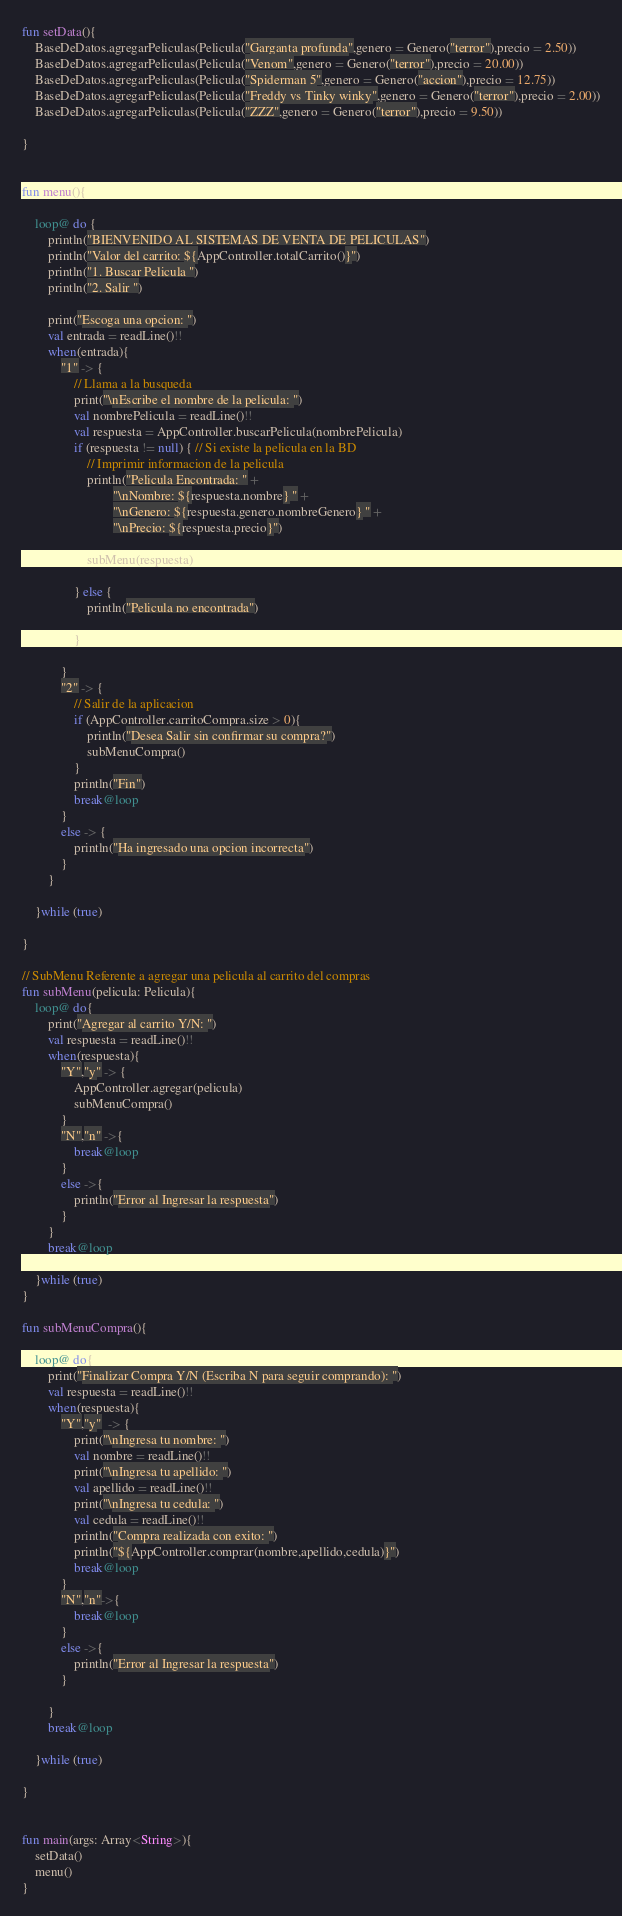Convert code to text. <code><loc_0><loc_0><loc_500><loc_500><_Kotlin_>fun setData(){
    BaseDeDatos.agregarPeliculas(Pelicula("Garganta profunda",genero = Genero("terror"),precio = 2.50))
    BaseDeDatos.agregarPeliculas(Pelicula("Venom",genero = Genero("terror"),precio = 20.00))
    BaseDeDatos.agregarPeliculas(Pelicula("Spiderman 5",genero = Genero("accion"),precio = 12.75))
    BaseDeDatos.agregarPeliculas(Pelicula("Freddy vs Tinky winky",genero = Genero("terror"),precio = 2.00))
    BaseDeDatos.agregarPeliculas(Pelicula("ZZZ",genero = Genero("terror"),precio = 9.50))

}


fun menu(){

    loop@ do {
        println("BIENVENIDO AL SISTEMAS DE VENTA DE PELICULAS")
        println("Valor del carrito: ${AppController.totalCarrito()}")
        println("1. Buscar Pelicula ")
        println("2. Salir ")

        print("Escoga una opcion: ")
        val entrada = readLine()!!
        when(entrada){
            "1" -> {
                // Llama a la busqueda
                print("\nEscribe el nombre de la pelicula: ")
                val nombrePelicula = readLine()!!
                val respuesta = AppController.buscarPelicula(nombrePelicula)
                if (respuesta != null) { // Si existe la pelicula en la BD
                    // Imprimir informacion de la pelicula
                    println("Pelicula Encontrada: " +
                            "\nNombre: ${respuesta.nombre} " +
                            "\nGenero: ${respuesta.genero.nombreGenero} " +
                            "\nPrecio: ${respuesta.precio}")

                    subMenu(respuesta)

                } else {
                    println("Pelicula no encontrada")

                }

            }
            "2" -> {
                // Salir de la aplicacion
                if (AppController.carritoCompra.size > 0){
                    println("Desea Salir sin confirmar su compra?")
                    subMenuCompra()
                }
                println("Fin")
                break@loop
            }
            else -> {
                println("Ha ingresado una opcion incorrecta")
            }
        }

    }while (true)

}

// SubMenu Referente a agregar una pelicula al carrito del compras
fun subMenu(pelicula: Pelicula){
    loop@ do{
        print("Agregar al carrito Y/N: ")
        val respuesta = readLine()!!
        when(respuesta){
            "Y","y" -> {
                AppController.agregar(pelicula)
                subMenuCompra()
            }
            "N","n" ->{
                break@loop
            }
            else ->{
                println("Error al Ingresar la respuesta")
            }
        }
        break@loop

    }while (true)
}

fun subMenuCompra(){

    loop@ do{
        print("Finalizar Compra Y/N (Escriba N para seguir comprando): ")
        val respuesta = readLine()!!
        when(respuesta){
            "Y","y"  -> {
                print("\nIngresa tu nombre: ")
                val nombre = readLine()!!
                print("\nIngresa tu apellido: ")
                val apellido = readLine()!!
                print("\nIngresa tu cedula: ")
                val cedula = readLine()!!
                println("Compra realizada con exito: ")
                println("${AppController.comprar(nombre,apellido,cedula)}")
                break@loop
            }
            "N","n"->{
                break@loop
            }
            else ->{
                println("Error al Ingresar la respuesta")
            }

        }
        break@loop

    }while (true)

}


fun main(args: Array<String>){
    setData()
    menu()
}


</code> 